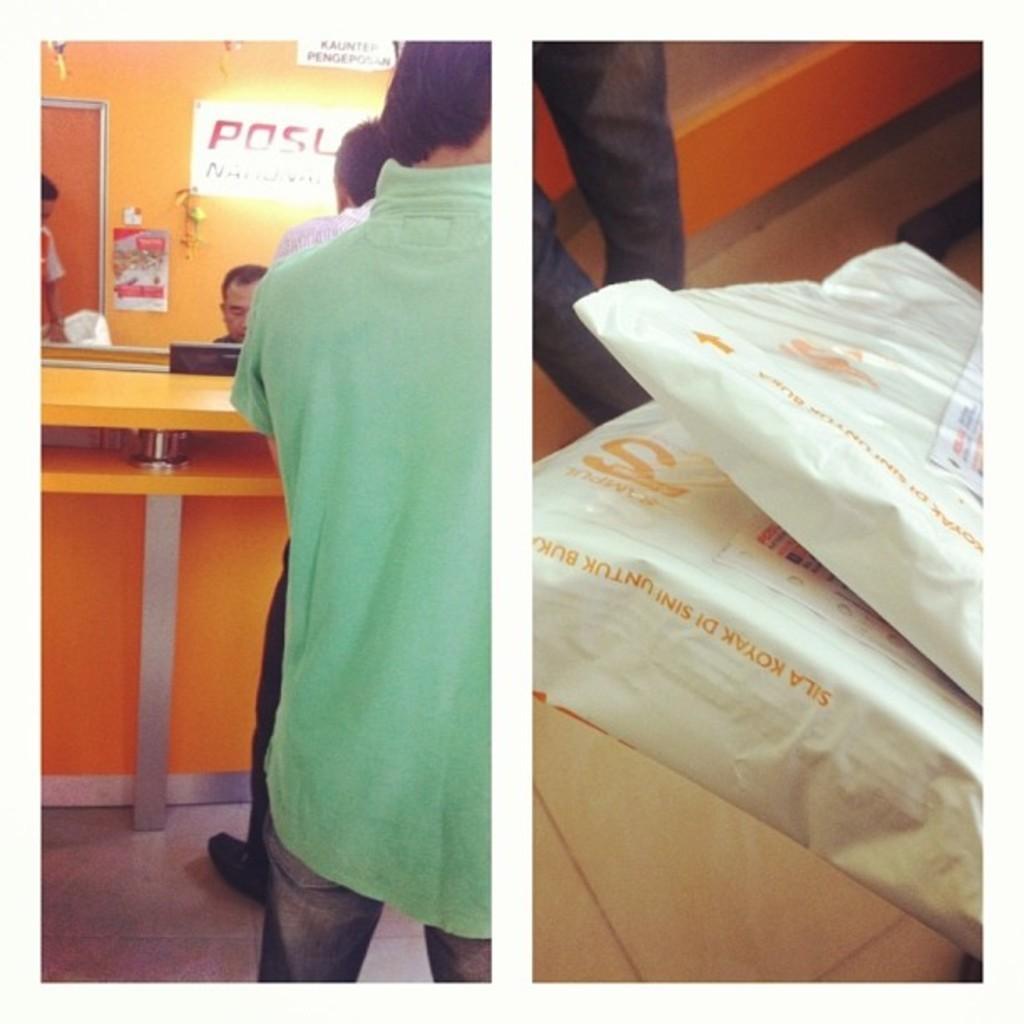Please provide a concise description of this image. This is a college, in this image there are some people, boards, wall and some boxes, plastic covers, and in the background there are some boards, posters, wall and some other objects. At the bottom there is floor. 